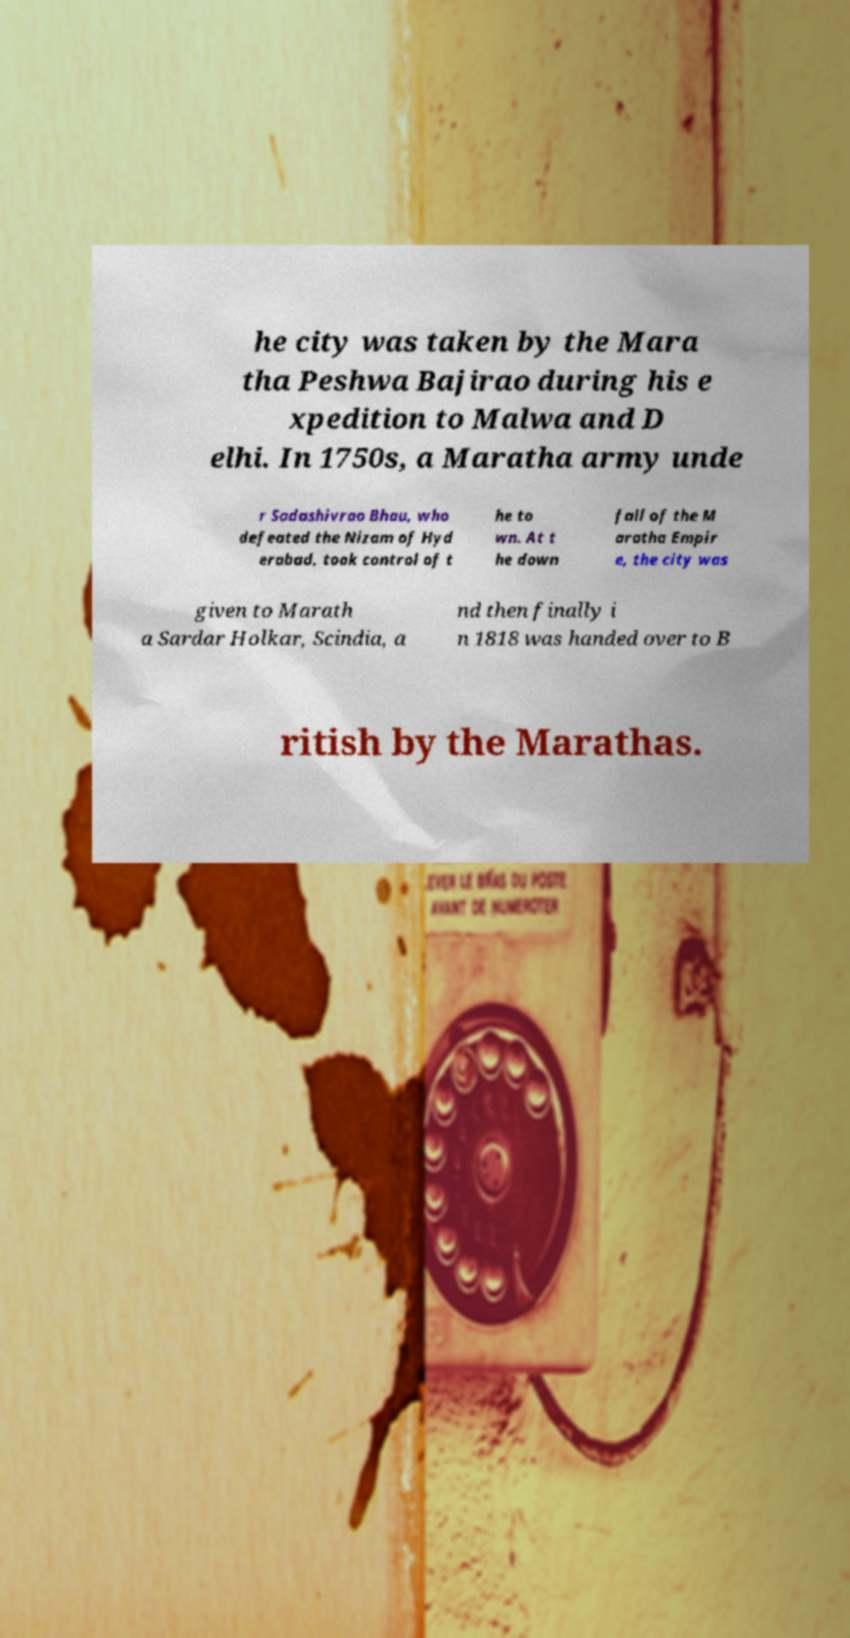Please identify and transcribe the text found in this image. he city was taken by the Mara tha Peshwa Bajirao during his e xpedition to Malwa and D elhi. In 1750s, a Maratha army unde r Sadashivrao Bhau, who defeated the Nizam of Hyd erabad, took control of t he to wn. At t he down fall of the M aratha Empir e, the city was given to Marath a Sardar Holkar, Scindia, a nd then finally i n 1818 was handed over to B ritish by the Marathas. 